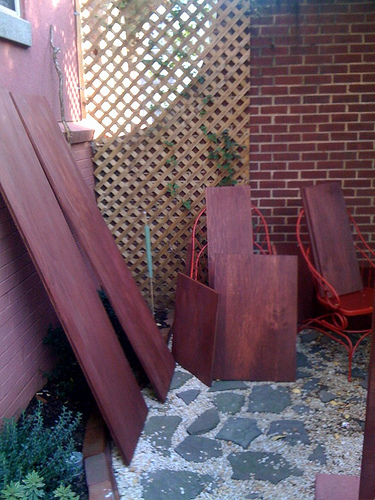<image>
Is the bricks in front of the woods? No. The bricks is not in front of the woods. The spatial positioning shows a different relationship between these objects. 